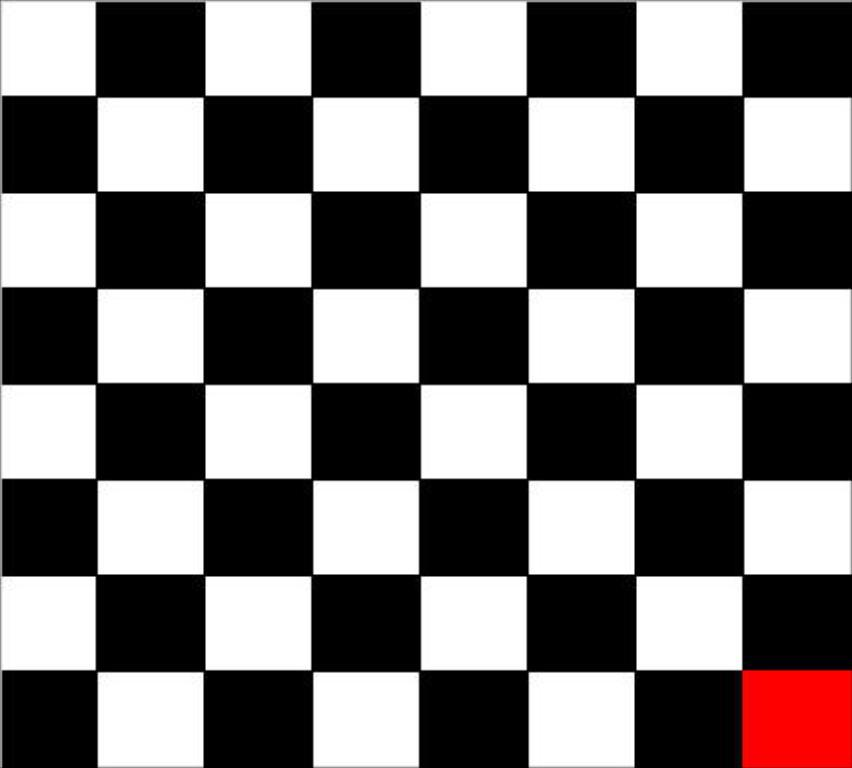What is the main subject of the image? There is a chess board in the image. Can you describe the chess board in more detail? Unfortunately, the provided facts do not give any additional details about the chess board. Are there any pieces on the chess board? The provided facts do not mention any chess pieces on the board. What type of steel is used to make the chess pieces in the image? There are no chess pieces present in the image, and therefore no steel can be associated with them. How many mittens can be seen on the chess board in the image? There are no mittens present in the image, and therefore none can be seen on the chess board. 